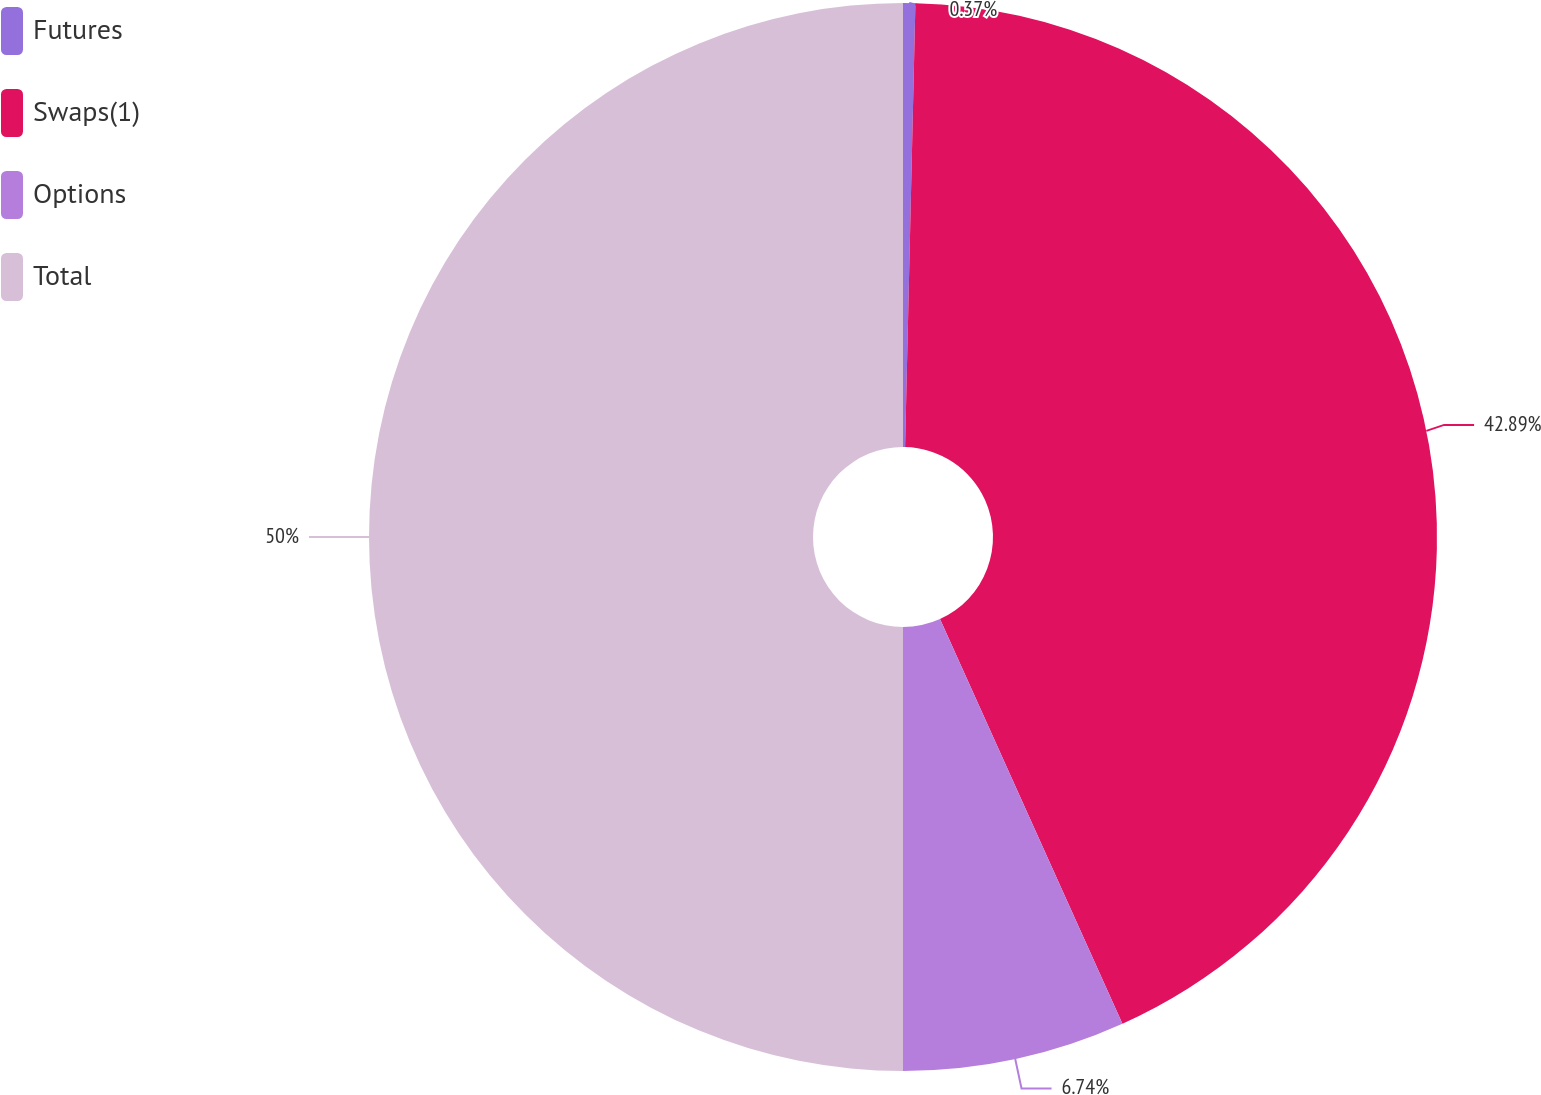<chart> <loc_0><loc_0><loc_500><loc_500><pie_chart><fcel>Futures<fcel>Swaps(1)<fcel>Options<fcel>Total<nl><fcel>0.37%<fcel>42.89%<fcel>6.74%<fcel>50.0%<nl></chart> 